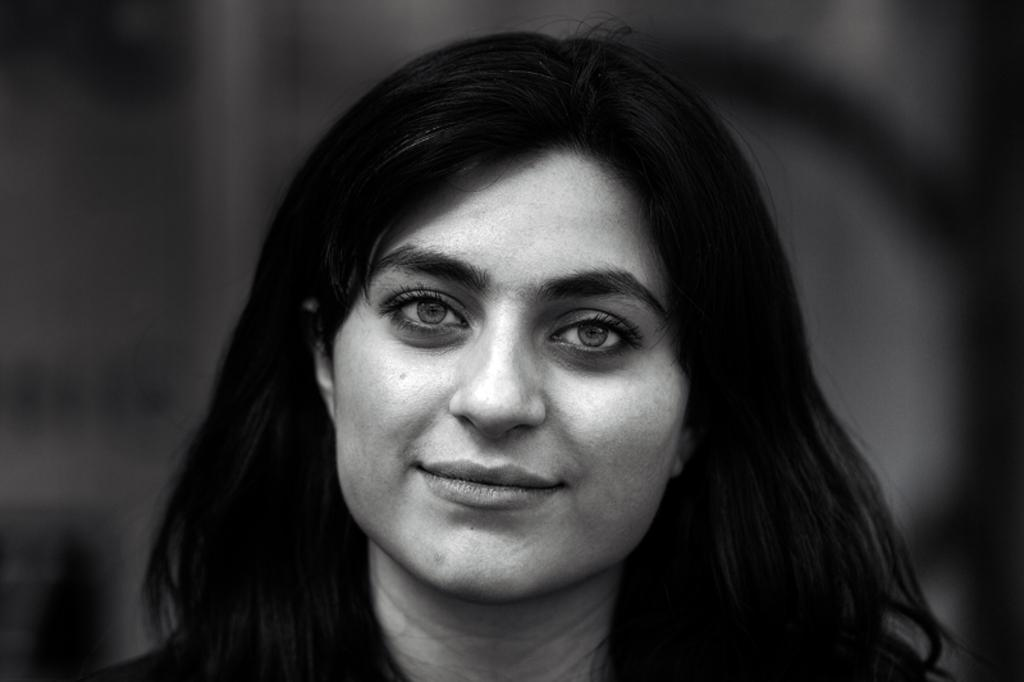What is the main subject of the image? There is a person's face in the image. Can you describe the background of the image? The background of the image is blurred. What type of company is depicted in the background of the image? There is no company depicted in the image, as the background is blurred. What reason might the person have for being in a field in the image? There is no indication of a field or any specific reason for the person's presence in the image, as the background is blurred and only the person's face is visible. 